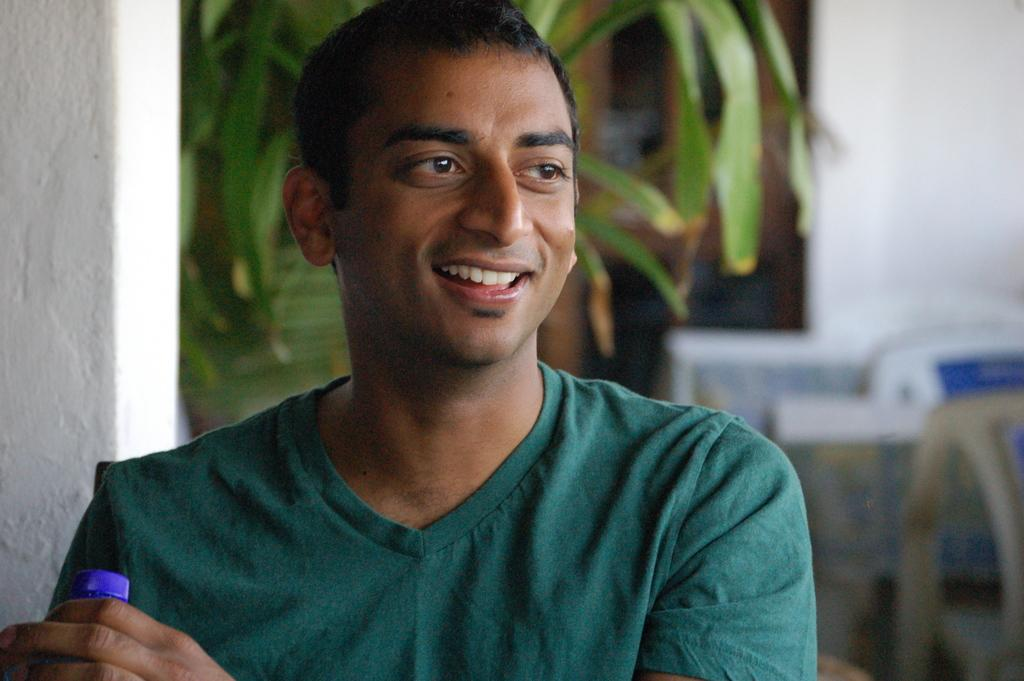Who is present in the image? There is a man in the image. What is the man holding in the image? The man is holding a disposal bottle. What can be seen in the background of the image? There are chairs, a plant, and walls in the background of the image. What type of committee is meeting in the image? There is no committee meeting in the image; it only features a man holding a disposal bottle and the background elements. 